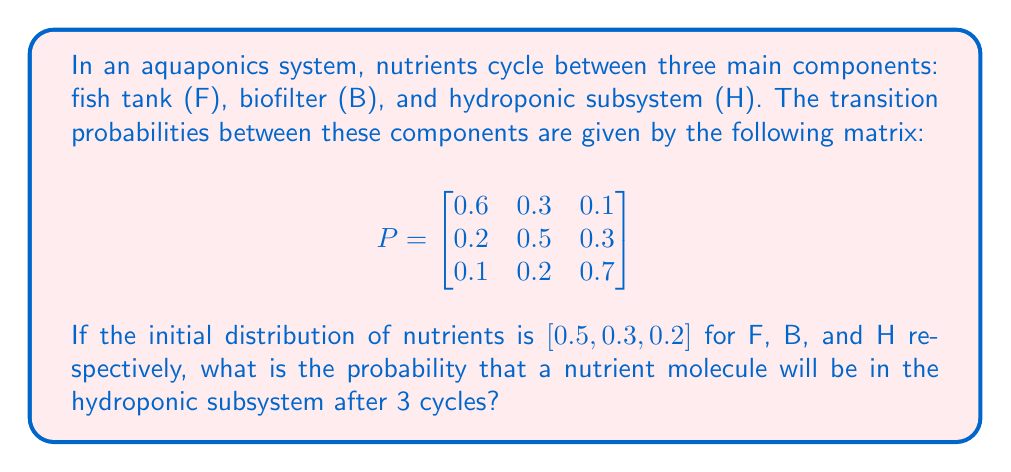Solve this math problem. To solve this problem, we need to use the Chapman-Kolmogorov equations for Markov chains. The steps are as follows:

1) First, we need to calculate $P^3$, which represents the transition probabilities after 3 cycles. We can do this by multiplying the matrix P by itself three times:

   $$P^3 = P \times P \times P$$

2) Using a calculator or computer, we find:

   $$P^3 = \begin{bmatrix}
   0.412 & 0.330 & 0.258 \\
   0.304 & 0.350 & 0.346 \\
   0.226 & 0.282 & 0.492
   \end{bmatrix}$$

3) Now, we need to multiply the initial distribution vector by $P^3$. Let's call the initial distribution vector $\pi_0$:

   $$\pi_0 = [0.5, 0.3, 0.2]$$

4) The distribution after 3 cycles, $\pi_3$, is given by:

   $$\pi_3 = \pi_0 \times P^3$$

5) Performing this multiplication:

   $$\pi_3 = [0.5, 0.3, 0.2] \times \begin{bmatrix}
   0.412 & 0.330 & 0.258 \\
   0.304 & 0.350 & 0.346 \\
   0.226 & 0.282 & 0.492
   \end{bmatrix}$$

6) Calculating this:

   $$\pi_3 = [0.346, 0.324, 0.330]$$

7) The probability of being in the hydroponic subsystem (H) after 3 cycles is the third element of this vector.
Answer: 0.330 